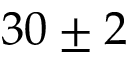<formula> <loc_0><loc_0><loc_500><loc_500>3 0 \pm 2</formula> 